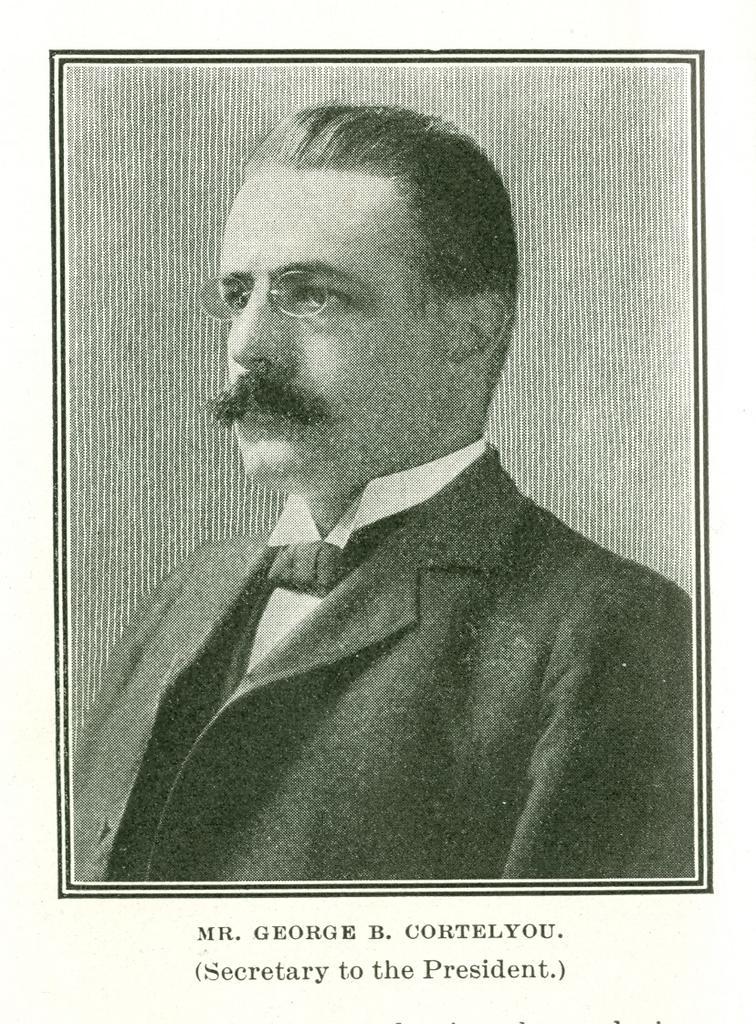Please provide a concise description of this image. In this image we can see a photograph of a man. He is wearing a jacket. At the bottom there is text. 